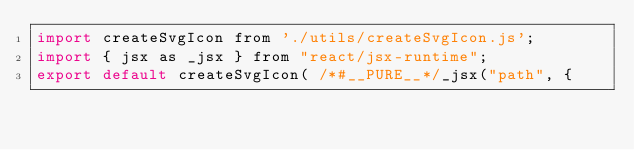<code> <loc_0><loc_0><loc_500><loc_500><_JavaScript_>import createSvgIcon from './utils/createSvgIcon.js';
import { jsx as _jsx } from "react/jsx-runtime";
export default createSvgIcon( /*#__PURE__*/_jsx("path", {</code> 